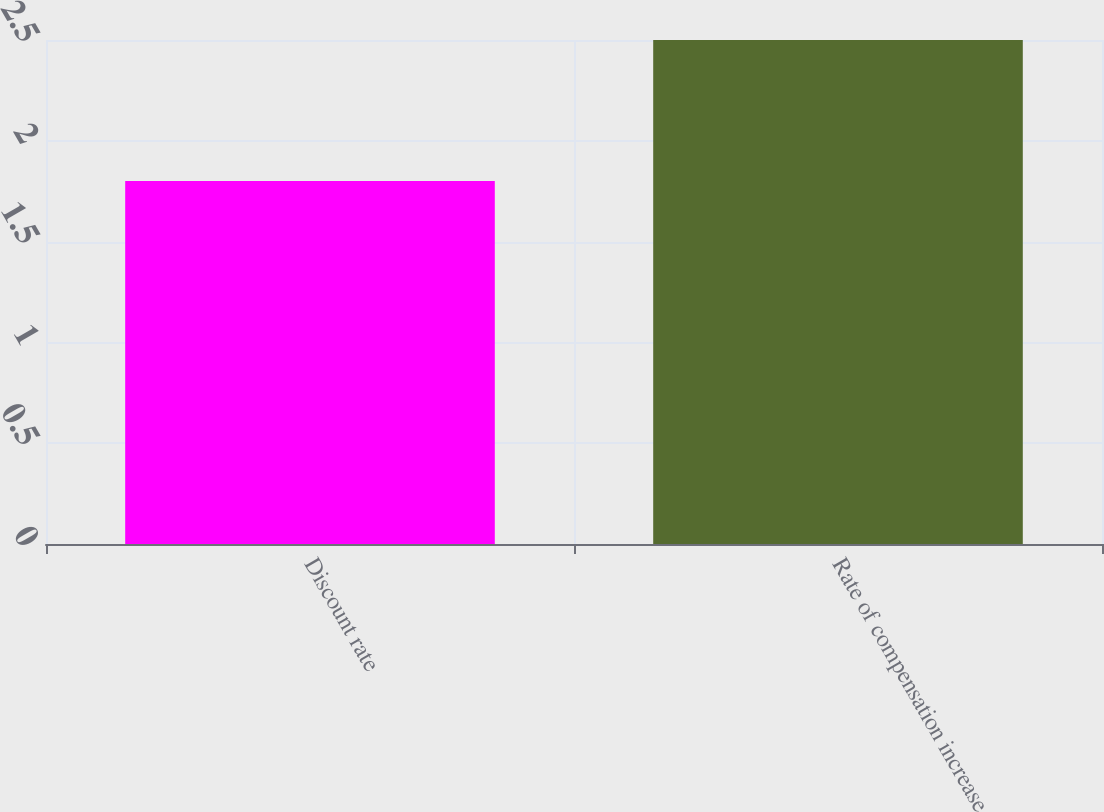<chart> <loc_0><loc_0><loc_500><loc_500><bar_chart><fcel>Discount rate<fcel>Rate of compensation increase<nl><fcel>1.8<fcel>2.5<nl></chart> 